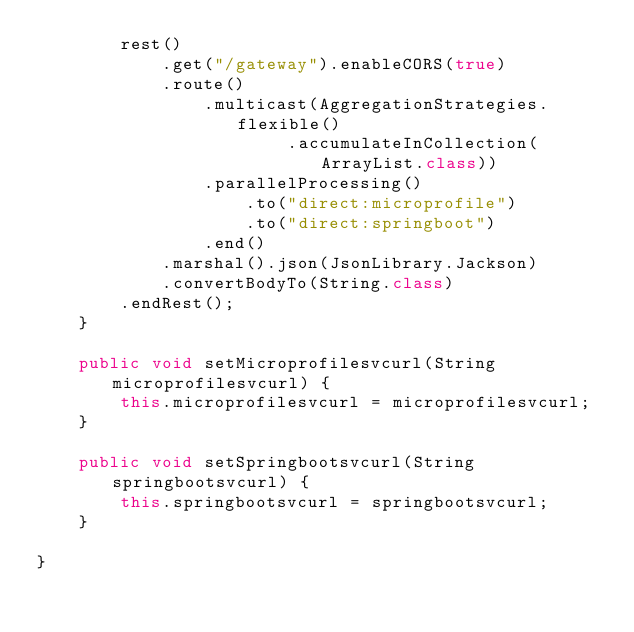Convert code to text. <code><loc_0><loc_0><loc_500><loc_500><_Java_>        rest()
            .get("/gateway").enableCORS(true)
            .route()
                .multicast(AggregationStrategies.flexible()
                        .accumulateInCollection(ArrayList.class))
                .parallelProcessing()
                    .to("direct:microprofile")
                    .to("direct:springboot")
                .end()
            .marshal().json(JsonLibrary.Jackson)
            .convertBodyTo(String.class)
        .endRest();
    }

    public void setMicroprofilesvcurl(String microprofilesvcurl) {
        this.microprofilesvcurl = microprofilesvcurl;
    }

    public void setSpringbootsvcurl(String springbootsvcurl) {
        this.springbootsvcurl = springbootsvcurl;
    }

}
</code> 